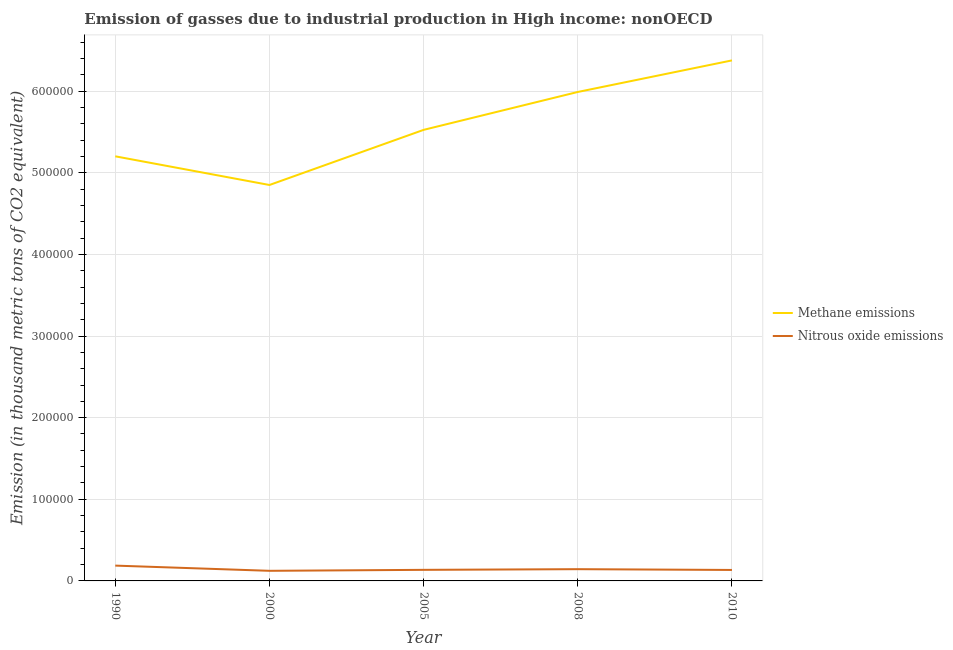What is the amount of methane emissions in 2008?
Offer a terse response. 5.99e+05. Across all years, what is the maximum amount of methane emissions?
Provide a succinct answer. 6.38e+05. Across all years, what is the minimum amount of nitrous oxide emissions?
Offer a very short reply. 1.24e+04. In which year was the amount of methane emissions maximum?
Give a very brief answer. 2010. What is the total amount of methane emissions in the graph?
Offer a very short reply. 2.79e+06. What is the difference between the amount of nitrous oxide emissions in 1990 and that in 2010?
Ensure brevity in your answer.  5319.5. What is the difference between the amount of methane emissions in 2008 and the amount of nitrous oxide emissions in 2010?
Ensure brevity in your answer.  5.86e+05. What is the average amount of methane emissions per year?
Give a very brief answer. 5.59e+05. In the year 2008, what is the difference between the amount of nitrous oxide emissions and amount of methane emissions?
Offer a very short reply. -5.85e+05. In how many years, is the amount of nitrous oxide emissions greater than 500000 thousand metric tons?
Your answer should be very brief. 0. What is the ratio of the amount of nitrous oxide emissions in 2005 to that in 2008?
Offer a very short reply. 0.94. Is the difference between the amount of methane emissions in 1990 and 2000 greater than the difference between the amount of nitrous oxide emissions in 1990 and 2000?
Ensure brevity in your answer.  Yes. What is the difference between the highest and the second highest amount of nitrous oxide emissions?
Offer a very short reply. 4366.8. What is the difference between the highest and the lowest amount of methane emissions?
Provide a short and direct response. 1.53e+05. Is the sum of the amount of nitrous oxide emissions in 2005 and 2008 greater than the maximum amount of methane emissions across all years?
Offer a terse response. No. Does the amount of nitrous oxide emissions monotonically increase over the years?
Provide a short and direct response. No. Is the amount of nitrous oxide emissions strictly greater than the amount of methane emissions over the years?
Give a very brief answer. No. Is the amount of nitrous oxide emissions strictly less than the amount of methane emissions over the years?
Keep it short and to the point. Yes. How many lines are there?
Offer a terse response. 2. Where does the legend appear in the graph?
Your response must be concise. Center right. What is the title of the graph?
Make the answer very short. Emission of gasses due to industrial production in High income: nonOECD. What is the label or title of the Y-axis?
Provide a succinct answer. Emission (in thousand metric tons of CO2 equivalent). What is the Emission (in thousand metric tons of CO2 equivalent) of Methane emissions in 1990?
Your response must be concise. 5.20e+05. What is the Emission (in thousand metric tons of CO2 equivalent) in Nitrous oxide emissions in 1990?
Your answer should be very brief. 1.88e+04. What is the Emission (in thousand metric tons of CO2 equivalent) in Methane emissions in 2000?
Your response must be concise. 4.85e+05. What is the Emission (in thousand metric tons of CO2 equivalent) of Nitrous oxide emissions in 2000?
Ensure brevity in your answer.  1.24e+04. What is the Emission (in thousand metric tons of CO2 equivalent) of Methane emissions in 2005?
Your answer should be very brief. 5.53e+05. What is the Emission (in thousand metric tons of CO2 equivalent) of Nitrous oxide emissions in 2005?
Make the answer very short. 1.36e+04. What is the Emission (in thousand metric tons of CO2 equivalent) of Methane emissions in 2008?
Provide a succinct answer. 5.99e+05. What is the Emission (in thousand metric tons of CO2 equivalent) in Nitrous oxide emissions in 2008?
Make the answer very short. 1.44e+04. What is the Emission (in thousand metric tons of CO2 equivalent) of Methane emissions in 2010?
Provide a succinct answer. 6.38e+05. What is the Emission (in thousand metric tons of CO2 equivalent) of Nitrous oxide emissions in 2010?
Offer a terse response. 1.34e+04. Across all years, what is the maximum Emission (in thousand metric tons of CO2 equivalent) of Methane emissions?
Keep it short and to the point. 6.38e+05. Across all years, what is the maximum Emission (in thousand metric tons of CO2 equivalent) in Nitrous oxide emissions?
Offer a terse response. 1.88e+04. Across all years, what is the minimum Emission (in thousand metric tons of CO2 equivalent) in Methane emissions?
Keep it short and to the point. 4.85e+05. Across all years, what is the minimum Emission (in thousand metric tons of CO2 equivalent) in Nitrous oxide emissions?
Your response must be concise. 1.24e+04. What is the total Emission (in thousand metric tons of CO2 equivalent) in Methane emissions in the graph?
Your response must be concise. 2.79e+06. What is the total Emission (in thousand metric tons of CO2 equivalent) of Nitrous oxide emissions in the graph?
Make the answer very short. 7.25e+04. What is the difference between the Emission (in thousand metric tons of CO2 equivalent) in Methane emissions in 1990 and that in 2000?
Offer a very short reply. 3.51e+04. What is the difference between the Emission (in thousand metric tons of CO2 equivalent) in Nitrous oxide emissions in 1990 and that in 2000?
Ensure brevity in your answer.  6373.1. What is the difference between the Emission (in thousand metric tons of CO2 equivalent) of Methane emissions in 1990 and that in 2005?
Offer a terse response. -3.24e+04. What is the difference between the Emission (in thousand metric tons of CO2 equivalent) in Nitrous oxide emissions in 1990 and that in 2005?
Give a very brief answer. 5181.3. What is the difference between the Emission (in thousand metric tons of CO2 equivalent) of Methane emissions in 1990 and that in 2008?
Provide a succinct answer. -7.88e+04. What is the difference between the Emission (in thousand metric tons of CO2 equivalent) of Nitrous oxide emissions in 1990 and that in 2008?
Give a very brief answer. 4366.8. What is the difference between the Emission (in thousand metric tons of CO2 equivalent) of Methane emissions in 1990 and that in 2010?
Make the answer very short. -1.18e+05. What is the difference between the Emission (in thousand metric tons of CO2 equivalent) of Nitrous oxide emissions in 1990 and that in 2010?
Ensure brevity in your answer.  5319.5. What is the difference between the Emission (in thousand metric tons of CO2 equivalent) of Methane emissions in 2000 and that in 2005?
Give a very brief answer. -6.75e+04. What is the difference between the Emission (in thousand metric tons of CO2 equivalent) in Nitrous oxide emissions in 2000 and that in 2005?
Ensure brevity in your answer.  -1191.8. What is the difference between the Emission (in thousand metric tons of CO2 equivalent) in Methane emissions in 2000 and that in 2008?
Offer a very short reply. -1.14e+05. What is the difference between the Emission (in thousand metric tons of CO2 equivalent) in Nitrous oxide emissions in 2000 and that in 2008?
Provide a succinct answer. -2006.3. What is the difference between the Emission (in thousand metric tons of CO2 equivalent) in Methane emissions in 2000 and that in 2010?
Your response must be concise. -1.53e+05. What is the difference between the Emission (in thousand metric tons of CO2 equivalent) of Nitrous oxide emissions in 2000 and that in 2010?
Your answer should be compact. -1053.6. What is the difference between the Emission (in thousand metric tons of CO2 equivalent) of Methane emissions in 2005 and that in 2008?
Give a very brief answer. -4.64e+04. What is the difference between the Emission (in thousand metric tons of CO2 equivalent) of Nitrous oxide emissions in 2005 and that in 2008?
Your answer should be compact. -814.5. What is the difference between the Emission (in thousand metric tons of CO2 equivalent) in Methane emissions in 2005 and that in 2010?
Provide a short and direct response. -8.51e+04. What is the difference between the Emission (in thousand metric tons of CO2 equivalent) in Nitrous oxide emissions in 2005 and that in 2010?
Keep it short and to the point. 138.2. What is the difference between the Emission (in thousand metric tons of CO2 equivalent) of Methane emissions in 2008 and that in 2010?
Your answer should be compact. -3.87e+04. What is the difference between the Emission (in thousand metric tons of CO2 equivalent) of Nitrous oxide emissions in 2008 and that in 2010?
Your response must be concise. 952.7. What is the difference between the Emission (in thousand metric tons of CO2 equivalent) of Methane emissions in 1990 and the Emission (in thousand metric tons of CO2 equivalent) of Nitrous oxide emissions in 2000?
Keep it short and to the point. 5.08e+05. What is the difference between the Emission (in thousand metric tons of CO2 equivalent) in Methane emissions in 1990 and the Emission (in thousand metric tons of CO2 equivalent) in Nitrous oxide emissions in 2005?
Provide a short and direct response. 5.07e+05. What is the difference between the Emission (in thousand metric tons of CO2 equivalent) in Methane emissions in 1990 and the Emission (in thousand metric tons of CO2 equivalent) in Nitrous oxide emissions in 2008?
Your answer should be compact. 5.06e+05. What is the difference between the Emission (in thousand metric tons of CO2 equivalent) of Methane emissions in 1990 and the Emission (in thousand metric tons of CO2 equivalent) of Nitrous oxide emissions in 2010?
Give a very brief answer. 5.07e+05. What is the difference between the Emission (in thousand metric tons of CO2 equivalent) of Methane emissions in 2000 and the Emission (in thousand metric tons of CO2 equivalent) of Nitrous oxide emissions in 2005?
Make the answer very short. 4.71e+05. What is the difference between the Emission (in thousand metric tons of CO2 equivalent) in Methane emissions in 2000 and the Emission (in thousand metric tons of CO2 equivalent) in Nitrous oxide emissions in 2008?
Your answer should be compact. 4.71e+05. What is the difference between the Emission (in thousand metric tons of CO2 equivalent) of Methane emissions in 2000 and the Emission (in thousand metric tons of CO2 equivalent) of Nitrous oxide emissions in 2010?
Your answer should be very brief. 4.72e+05. What is the difference between the Emission (in thousand metric tons of CO2 equivalent) of Methane emissions in 2005 and the Emission (in thousand metric tons of CO2 equivalent) of Nitrous oxide emissions in 2008?
Offer a very short reply. 5.38e+05. What is the difference between the Emission (in thousand metric tons of CO2 equivalent) in Methane emissions in 2005 and the Emission (in thousand metric tons of CO2 equivalent) in Nitrous oxide emissions in 2010?
Provide a short and direct response. 5.39e+05. What is the difference between the Emission (in thousand metric tons of CO2 equivalent) of Methane emissions in 2008 and the Emission (in thousand metric tons of CO2 equivalent) of Nitrous oxide emissions in 2010?
Offer a terse response. 5.86e+05. What is the average Emission (in thousand metric tons of CO2 equivalent) in Methane emissions per year?
Your answer should be compact. 5.59e+05. What is the average Emission (in thousand metric tons of CO2 equivalent) in Nitrous oxide emissions per year?
Keep it short and to the point. 1.45e+04. In the year 1990, what is the difference between the Emission (in thousand metric tons of CO2 equivalent) in Methane emissions and Emission (in thousand metric tons of CO2 equivalent) in Nitrous oxide emissions?
Offer a very short reply. 5.01e+05. In the year 2000, what is the difference between the Emission (in thousand metric tons of CO2 equivalent) in Methane emissions and Emission (in thousand metric tons of CO2 equivalent) in Nitrous oxide emissions?
Give a very brief answer. 4.73e+05. In the year 2005, what is the difference between the Emission (in thousand metric tons of CO2 equivalent) of Methane emissions and Emission (in thousand metric tons of CO2 equivalent) of Nitrous oxide emissions?
Your answer should be very brief. 5.39e+05. In the year 2008, what is the difference between the Emission (in thousand metric tons of CO2 equivalent) in Methane emissions and Emission (in thousand metric tons of CO2 equivalent) in Nitrous oxide emissions?
Your answer should be very brief. 5.85e+05. In the year 2010, what is the difference between the Emission (in thousand metric tons of CO2 equivalent) in Methane emissions and Emission (in thousand metric tons of CO2 equivalent) in Nitrous oxide emissions?
Your response must be concise. 6.24e+05. What is the ratio of the Emission (in thousand metric tons of CO2 equivalent) in Methane emissions in 1990 to that in 2000?
Your response must be concise. 1.07. What is the ratio of the Emission (in thousand metric tons of CO2 equivalent) in Nitrous oxide emissions in 1990 to that in 2000?
Offer a terse response. 1.51. What is the ratio of the Emission (in thousand metric tons of CO2 equivalent) in Methane emissions in 1990 to that in 2005?
Your answer should be compact. 0.94. What is the ratio of the Emission (in thousand metric tons of CO2 equivalent) in Nitrous oxide emissions in 1990 to that in 2005?
Make the answer very short. 1.38. What is the ratio of the Emission (in thousand metric tons of CO2 equivalent) of Methane emissions in 1990 to that in 2008?
Your response must be concise. 0.87. What is the ratio of the Emission (in thousand metric tons of CO2 equivalent) of Nitrous oxide emissions in 1990 to that in 2008?
Your response must be concise. 1.3. What is the ratio of the Emission (in thousand metric tons of CO2 equivalent) of Methane emissions in 1990 to that in 2010?
Provide a succinct answer. 0.82. What is the ratio of the Emission (in thousand metric tons of CO2 equivalent) of Nitrous oxide emissions in 1990 to that in 2010?
Provide a succinct answer. 1.4. What is the ratio of the Emission (in thousand metric tons of CO2 equivalent) of Methane emissions in 2000 to that in 2005?
Your answer should be very brief. 0.88. What is the ratio of the Emission (in thousand metric tons of CO2 equivalent) of Nitrous oxide emissions in 2000 to that in 2005?
Your response must be concise. 0.91. What is the ratio of the Emission (in thousand metric tons of CO2 equivalent) of Methane emissions in 2000 to that in 2008?
Offer a very short reply. 0.81. What is the ratio of the Emission (in thousand metric tons of CO2 equivalent) in Nitrous oxide emissions in 2000 to that in 2008?
Ensure brevity in your answer.  0.86. What is the ratio of the Emission (in thousand metric tons of CO2 equivalent) of Methane emissions in 2000 to that in 2010?
Give a very brief answer. 0.76. What is the ratio of the Emission (in thousand metric tons of CO2 equivalent) of Nitrous oxide emissions in 2000 to that in 2010?
Make the answer very short. 0.92. What is the ratio of the Emission (in thousand metric tons of CO2 equivalent) of Methane emissions in 2005 to that in 2008?
Keep it short and to the point. 0.92. What is the ratio of the Emission (in thousand metric tons of CO2 equivalent) in Nitrous oxide emissions in 2005 to that in 2008?
Provide a short and direct response. 0.94. What is the ratio of the Emission (in thousand metric tons of CO2 equivalent) in Methane emissions in 2005 to that in 2010?
Your answer should be very brief. 0.87. What is the ratio of the Emission (in thousand metric tons of CO2 equivalent) in Nitrous oxide emissions in 2005 to that in 2010?
Make the answer very short. 1.01. What is the ratio of the Emission (in thousand metric tons of CO2 equivalent) of Methane emissions in 2008 to that in 2010?
Your response must be concise. 0.94. What is the ratio of the Emission (in thousand metric tons of CO2 equivalent) in Nitrous oxide emissions in 2008 to that in 2010?
Your answer should be very brief. 1.07. What is the difference between the highest and the second highest Emission (in thousand metric tons of CO2 equivalent) in Methane emissions?
Provide a succinct answer. 3.87e+04. What is the difference between the highest and the second highest Emission (in thousand metric tons of CO2 equivalent) in Nitrous oxide emissions?
Give a very brief answer. 4366.8. What is the difference between the highest and the lowest Emission (in thousand metric tons of CO2 equivalent) of Methane emissions?
Your answer should be very brief. 1.53e+05. What is the difference between the highest and the lowest Emission (in thousand metric tons of CO2 equivalent) in Nitrous oxide emissions?
Provide a short and direct response. 6373.1. 